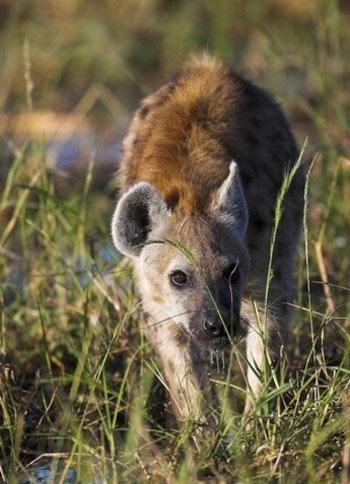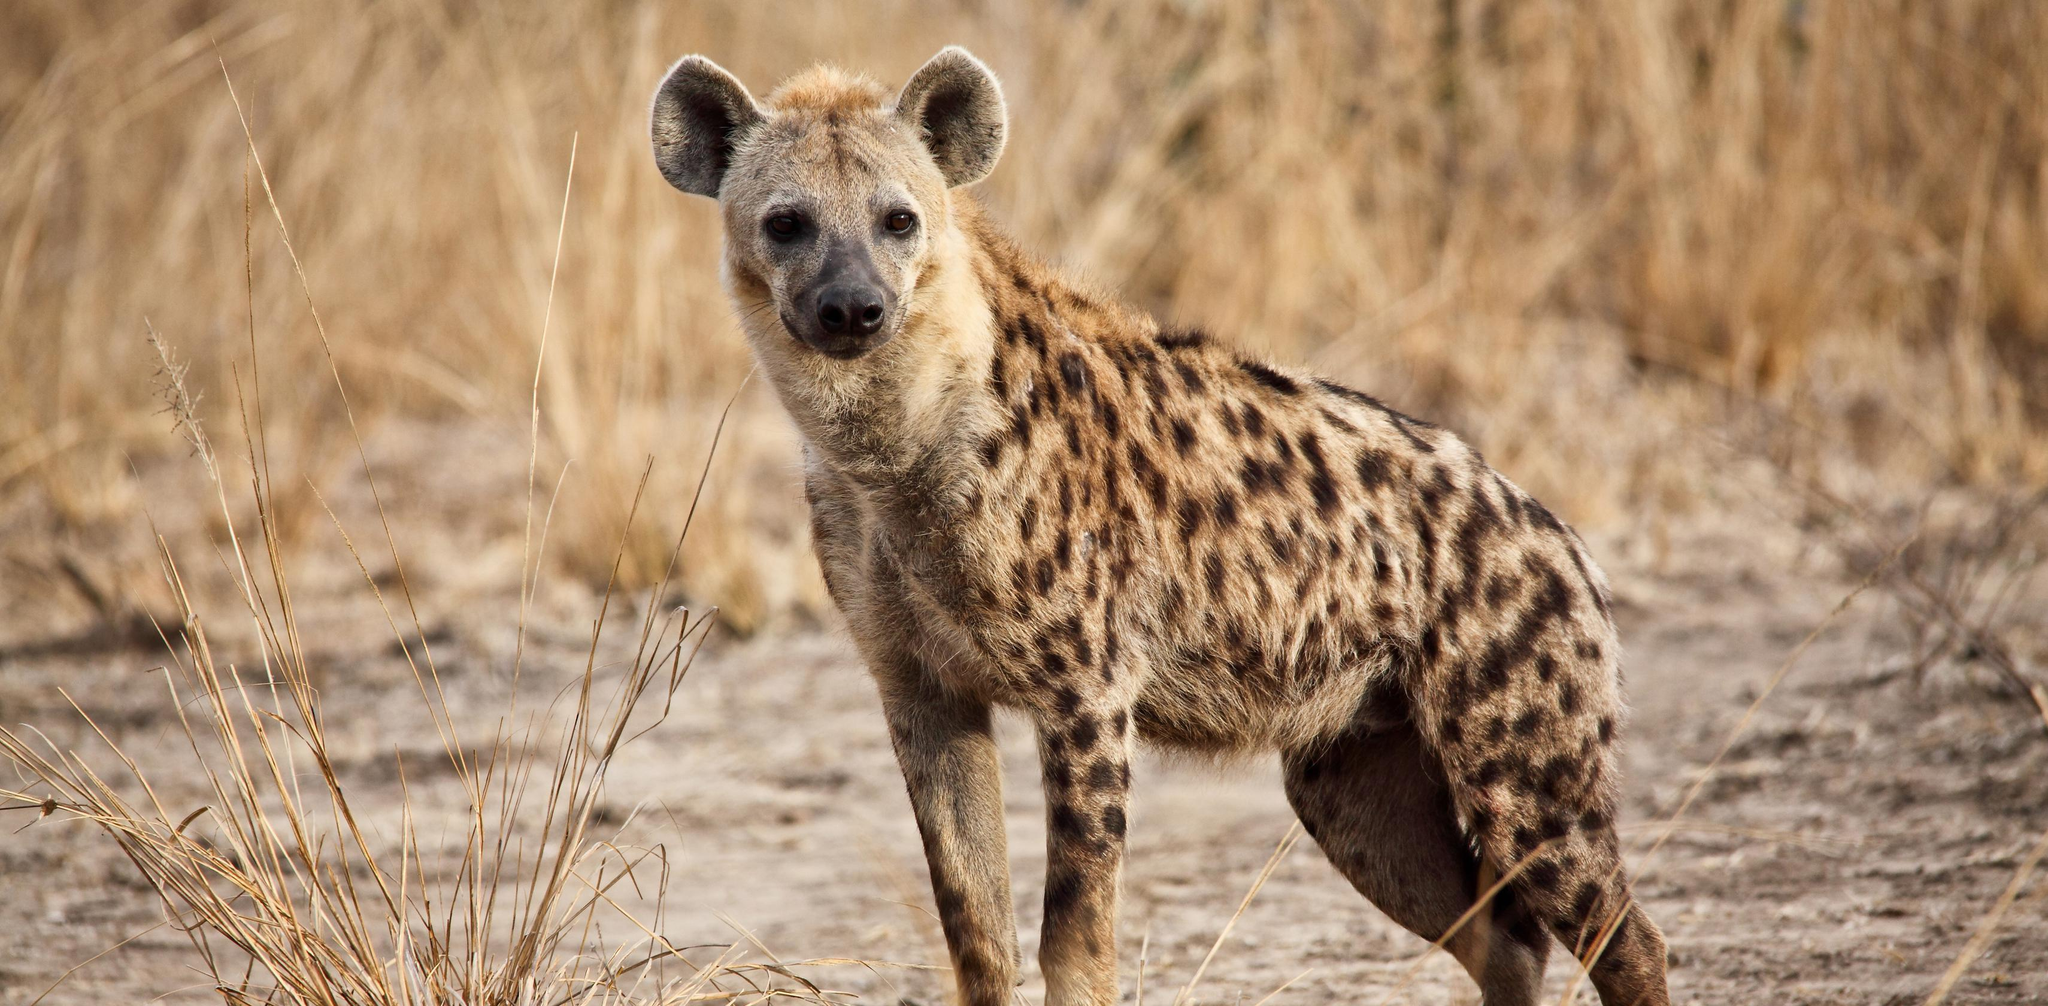The first image is the image on the left, the second image is the image on the right. Assess this claim about the two images: "The hyena on the right image is facing left.". Correct or not? Answer yes or no. Yes. 